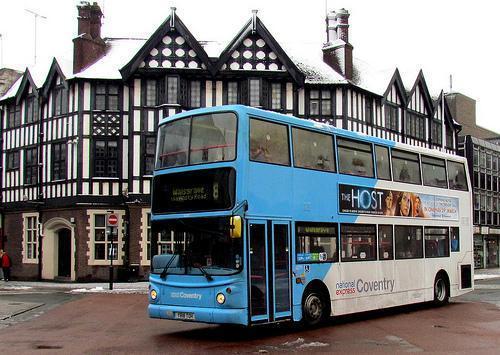How many red buses are there?
Give a very brief answer. 0. 